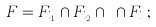<formula> <loc_0><loc_0><loc_500><loc_500>F = F _ { i _ { 1 } } \cap F _ { i _ { 2 } } \cap \cdots \cap F _ { i _ { l } } ;</formula> 